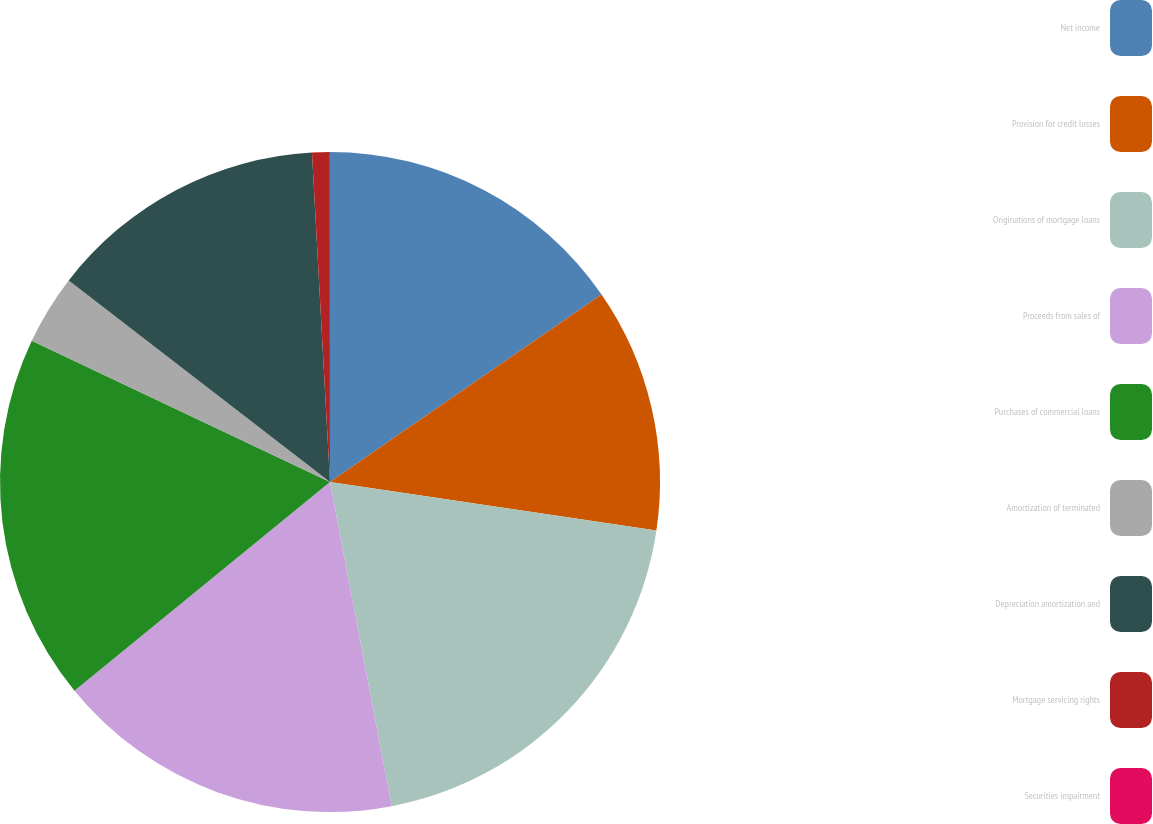Convert chart to OTSL. <chart><loc_0><loc_0><loc_500><loc_500><pie_chart><fcel>Net income<fcel>Provision for credit losses<fcel>Originations of mortgage loans<fcel>Proceeds from sales of<fcel>Purchases of commercial loans<fcel>Amortization of terminated<fcel>Depreciation amortization and<fcel>Mortgage servicing rights<fcel>Securities impairment<nl><fcel>15.38%<fcel>11.97%<fcel>19.65%<fcel>17.09%<fcel>17.94%<fcel>3.42%<fcel>13.67%<fcel>0.86%<fcel>0.01%<nl></chart> 